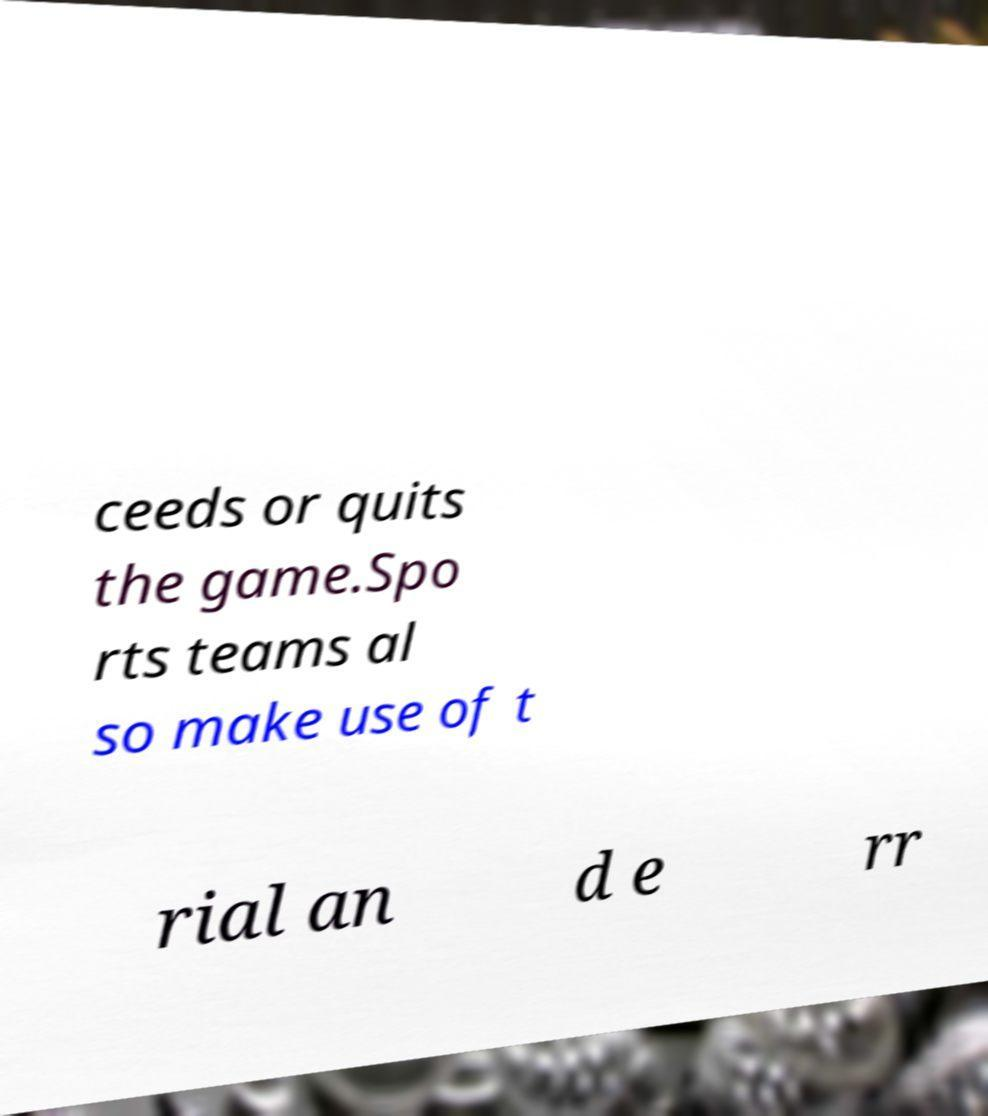There's text embedded in this image that I need extracted. Can you transcribe it verbatim? ceeds or quits the game.Spo rts teams al so make use of t rial an d e rr 